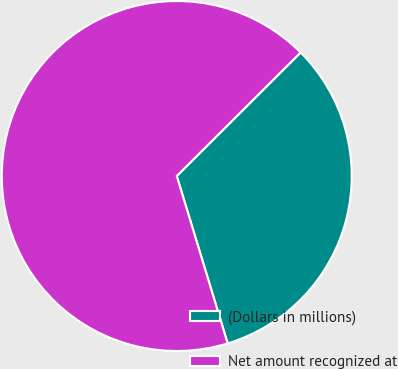Convert chart. <chart><loc_0><loc_0><loc_500><loc_500><pie_chart><fcel>(Dollars in millions)<fcel>Net amount recognized at<nl><fcel>32.78%<fcel>67.22%<nl></chart> 